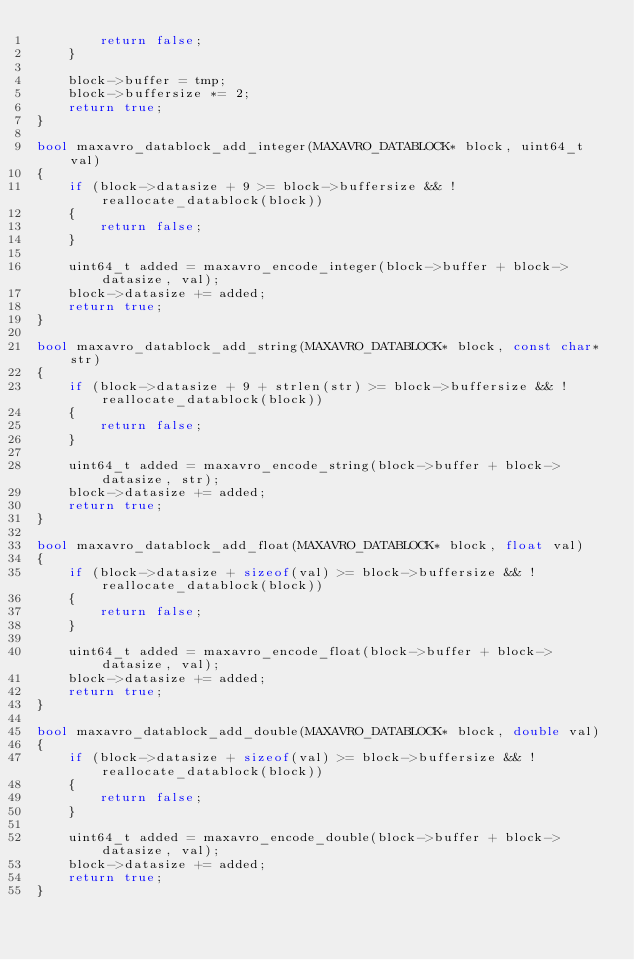Convert code to text. <code><loc_0><loc_0><loc_500><loc_500><_C++_>        return false;
    }

    block->buffer = tmp;
    block->buffersize *= 2;
    return true;
}

bool maxavro_datablock_add_integer(MAXAVRO_DATABLOCK* block, uint64_t val)
{
    if (block->datasize + 9 >= block->buffersize && !reallocate_datablock(block))
    {
        return false;
    }

    uint64_t added = maxavro_encode_integer(block->buffer + block->datasize, val);
    block->datasize += added;
    return true;
}

bool maxavro_datablock_add_string(MAXAVRO_DATABLOCK* block, const char* str)
{
    if (block->datasize + 9 + strlen(str) >= block->buffersize && !reallocate_datablock(block))
    {
        return false;
    }

    uint64_t added = maxavro_encode_string(block->buffer + block->datasize, str);
    block->datasize += added;
    return true;
}

bool maxavro_datablock_add_float(MAXAVRO_DATABLOCK* block, float val)
{
    if (block->datasize + sizeof(val) >= block->buffersize && !reallocate_datablock(block))
    {
        return false;
    }

    uint64_t added = maxavro_encode_float(block->buffer + block->datasize, val);
    block->datasize += added;
    return true;
}

bool maxavro_datablock_add_double(MAXAVRO_DATABLOCK* block, double val)
{
    if (block->datasize + sizeof(val) >= block->buffersize && !reallocate_datablock(block))
    {
        return false;
    }

    uint64_t added = maxavro_encode_double(block->buffer + block->datasize, val);
    block->datasize += added;
    return true;
}
</code> 